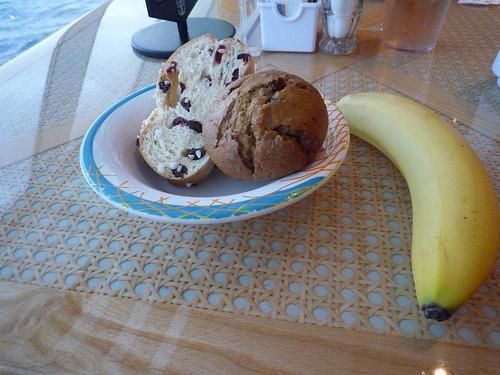How many fruit is there?
Give a very brief answer. 1. 